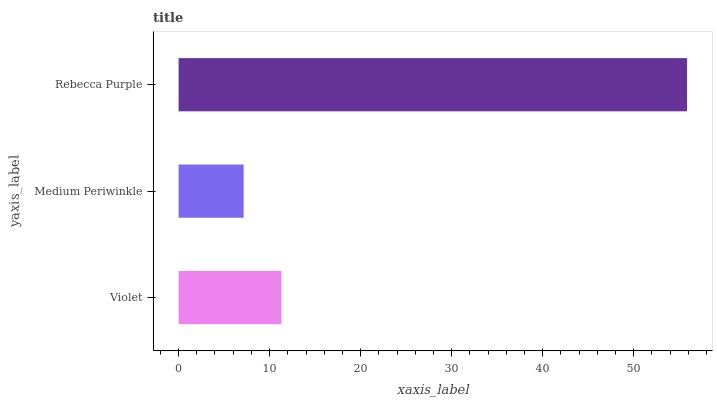Is Medium Periwinkle the minimum?
Answer yes or no. Yes. Is Rebecca Purple the maximum?
Answer yes or no. Yes. Is Rebecca Purple the minimum?
Answer yes or no. No. Is Medium Periwinkle the maximum?
Answer yes or no. No. Is Rebecca Purple greater than Medium Periwinkle?
Answer yes or no. Yes. Is Medium Periwinkle less than Rebecca Purple?
Answer yes or no. Yes. Is Medium Periwinkle greater than Rebecca Purple?
Answer yes or no. No. Is Rebecca Purple less than Medium Periwinkle?
Answer yes or no. No. Is Violet the high median?
Answer yes or no. Yes. Is Violet the low median?
Answer yes or no. Yes. Is Medium Periwinkle the high median?
Answer yes or no. No. Is Rebecca Purple the low median?
Answer yes or no. No. 